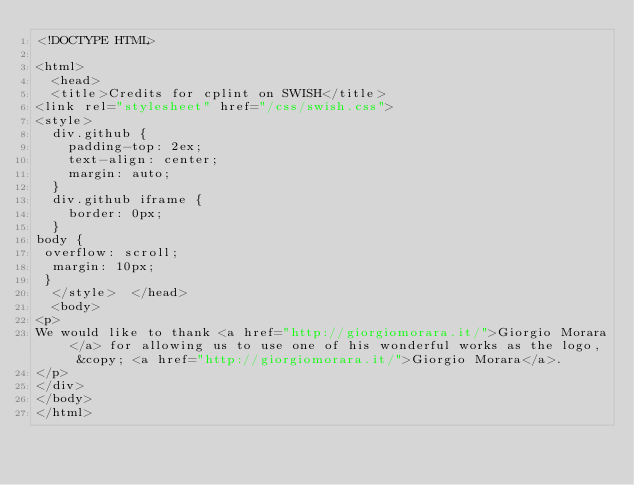<code> <loc_0><loc_0><loc_500><loc_500><_HTML_><!DOCTYPE HTML>

<html>
  <head>
  <title>Credits for cplint on SWISH</title>
<link rel="stylesheet" href="/css/swish.css">
<style>
  div.github {
    padding-top: 2ex;
    text-align: center;
    margin: auto;
  }
  div.github iframe {
    border: 0px;
  }
body {
 overflow: scroll;
  margin: 10px;
 }
  </style>  </head>
  <body>
<p>
We would like to thank <a href="http://giorgiomorara.it/">Giorgio Morara</a> for allowing us to use one of his wonderful works as the logo, &copy; <a href="http://giorgiomorara.it/">Giorgio Morara</a>.
</p>
</div>
</body>
</html>



</code> 